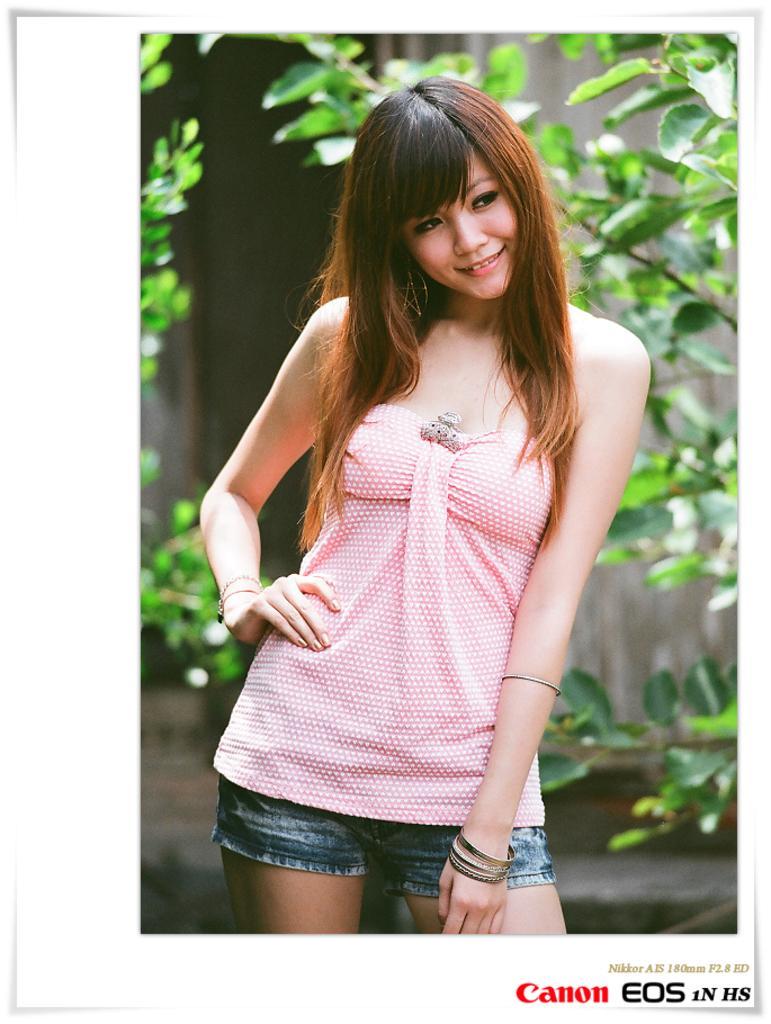Please provide a concise description of this image. In this picture we can see a woman standing and smiling. In the background we can see trees and the wall. At the bottom right corner of this picture we can see some text. 